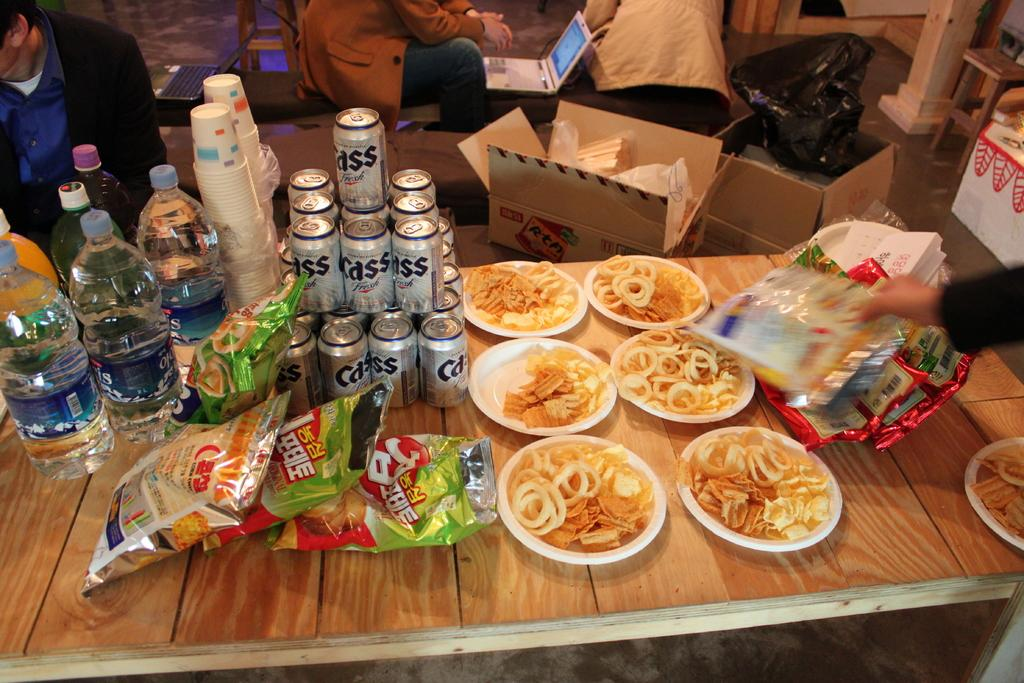What type of objects are on the table in the image? There are bottles, cups, tins, plates, and plastic packets on the table in the image. Are there any other objects near the table? Yes, there are boxes near the table. Who is present near the table? There are people near the table. What electronic devices can be seen in the image? There are laptops visible in the image. Can you tell me the color of the suit worn by the person in the image? There is no person wearing a suit in the image. What type of rod is being used to stir the contents of the plastic packets? There is no rod present in the image, and the plastic packets do not contain any stirrable contents. 